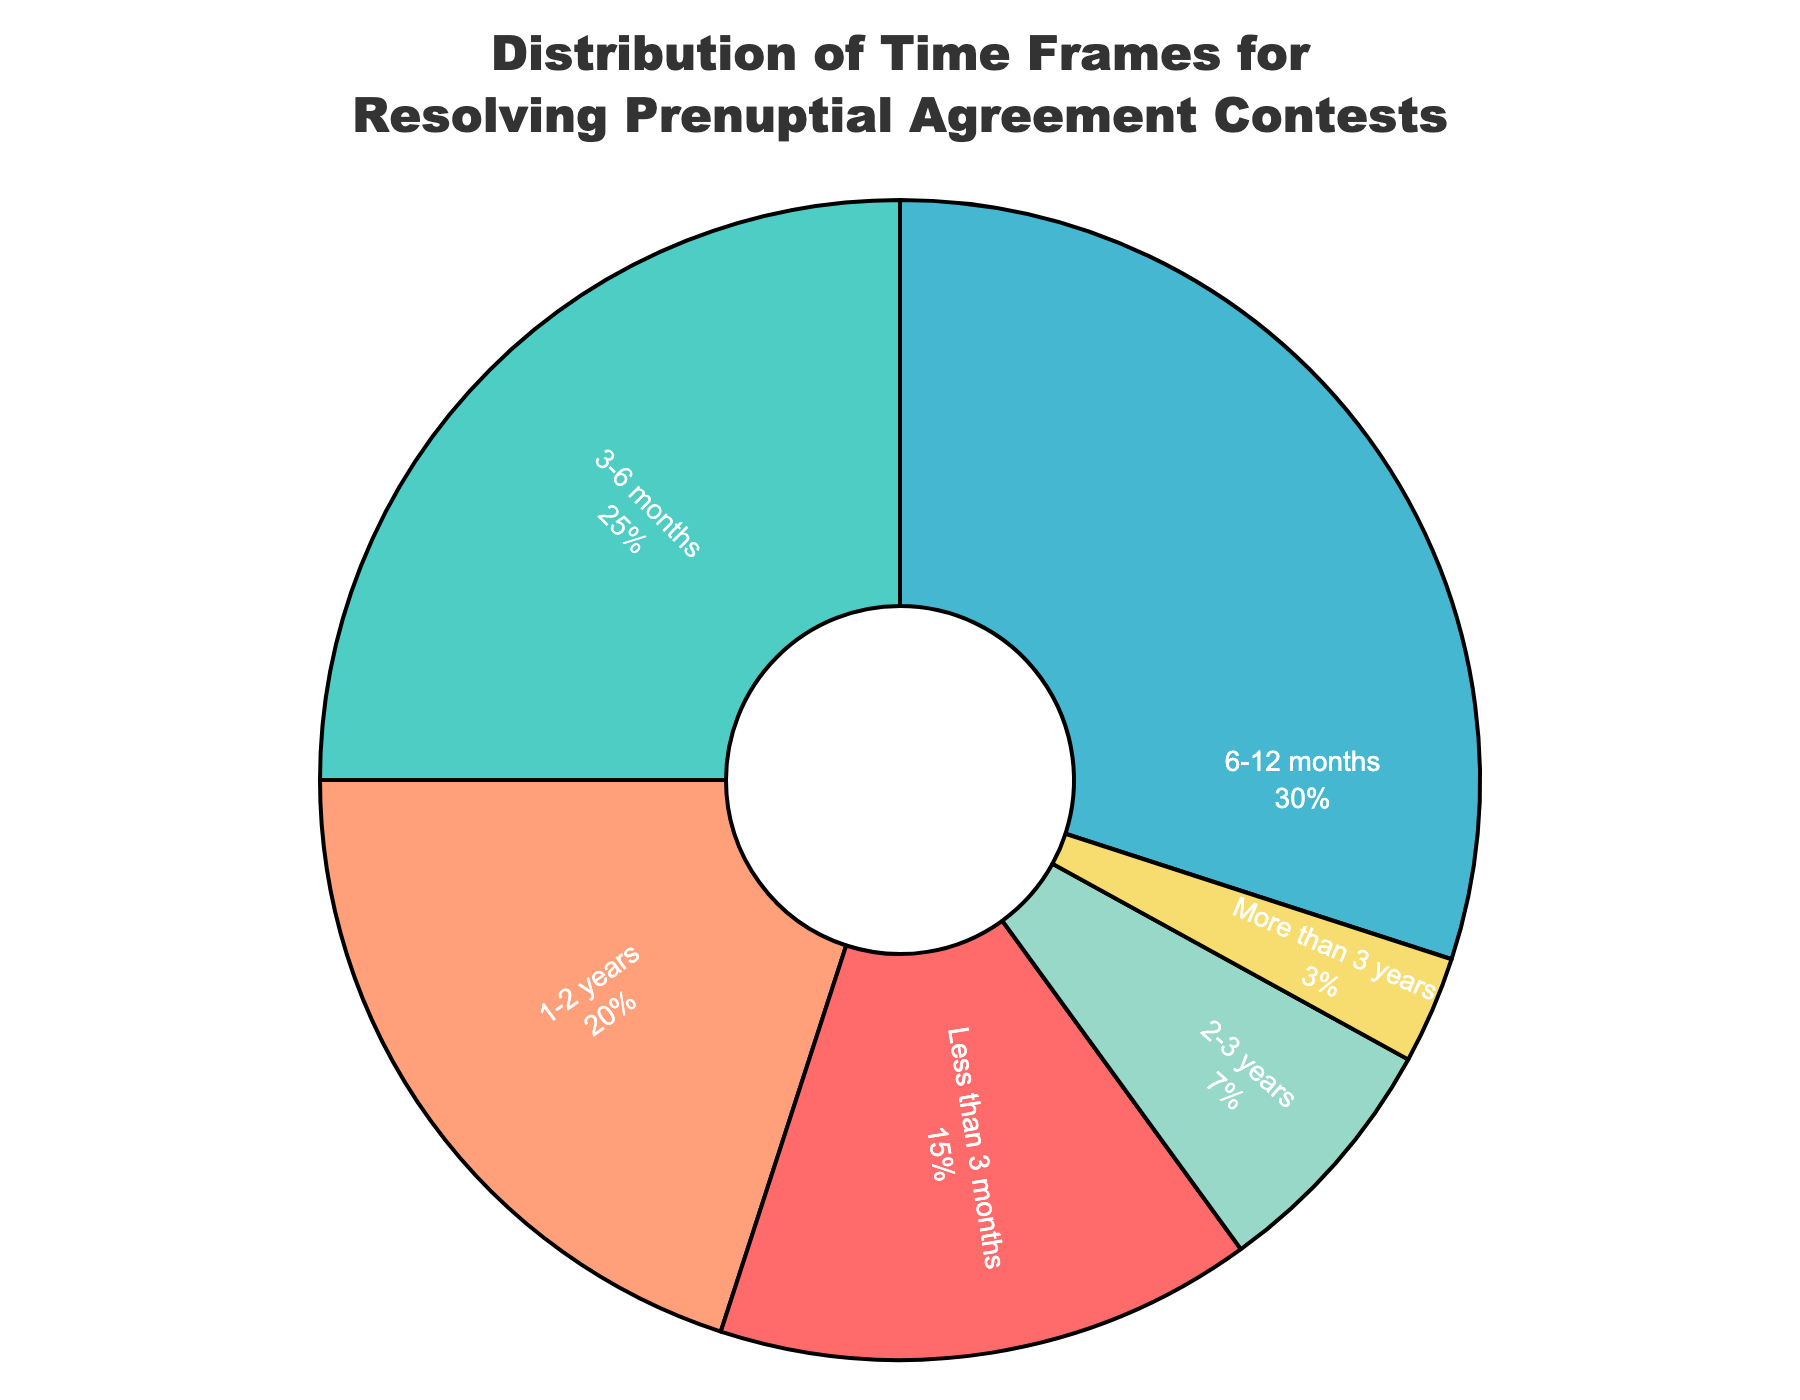What's the most common time frame for resolving prenuptial agreement contests? The largest section of the pie chart represents the most common time frame. The 6-12 months category has the largest percentage at 30%.
Answer: 6-12 months What percentage of cases are resolved in less than 6 months? Add the percentages of the "Less than 3 months" and "3-6 months" categories. 15% + 25% = 40%.
Answer: 40% Which time frame is twice as likely as the "2-3 years" category? Compare the percentages. The "1-2 years" category is 20%, which is more than twice the "2-3 years" category at 7%.
Answer: 1-2 years How many time frames have a percentage less than 10%? Look for categories with percentages less than 10%. There are two: "2-3 years" at 7% and "More than 3 years" at 3%.
Answer: 2 What is the combined percentage of cases resolved in 1 year or less? Add the percentages of the first three categories: "Less than 3 months" (15%), "3-6 months" (25%), and "6-12 months" (30%). 15% + 25% + 30% = 70%.
Answer: 70% Which time frame has the smallest percentage, and what is it? Identify the smallest section of the pie chart. The "More than 3 years" category is the smallest at 3%.
Answer: More than 3 years, 3% How does the percentage of cases resolved within 3-6 months compare to those resolved in 1-2 years? Compare the percentages of the two categories. "3-6 months" is 25% and "1-2 years" is 20%. 25% is greater than 20%.
Answer: 3-6 months is greater If you add the percentage of cases resolved in 3-6 months to those resolved in 1-2 years, what is the result? Add the percentages of the two categories: 25% + 20%. 25% + 20% = 45%.
Answer: 45% What time frame has a percentage three times that of "More than 3 years"? Find the category that has a percentage three times 3%. 9% is close to three times 3%, and "2-3 years" has 7%, which is slightly less. "Less than 3 months" is five times more and "3-6 months" is significantly more than three times. Hence none exactly match, recognize this invalid hypothesis.
Answer: None 